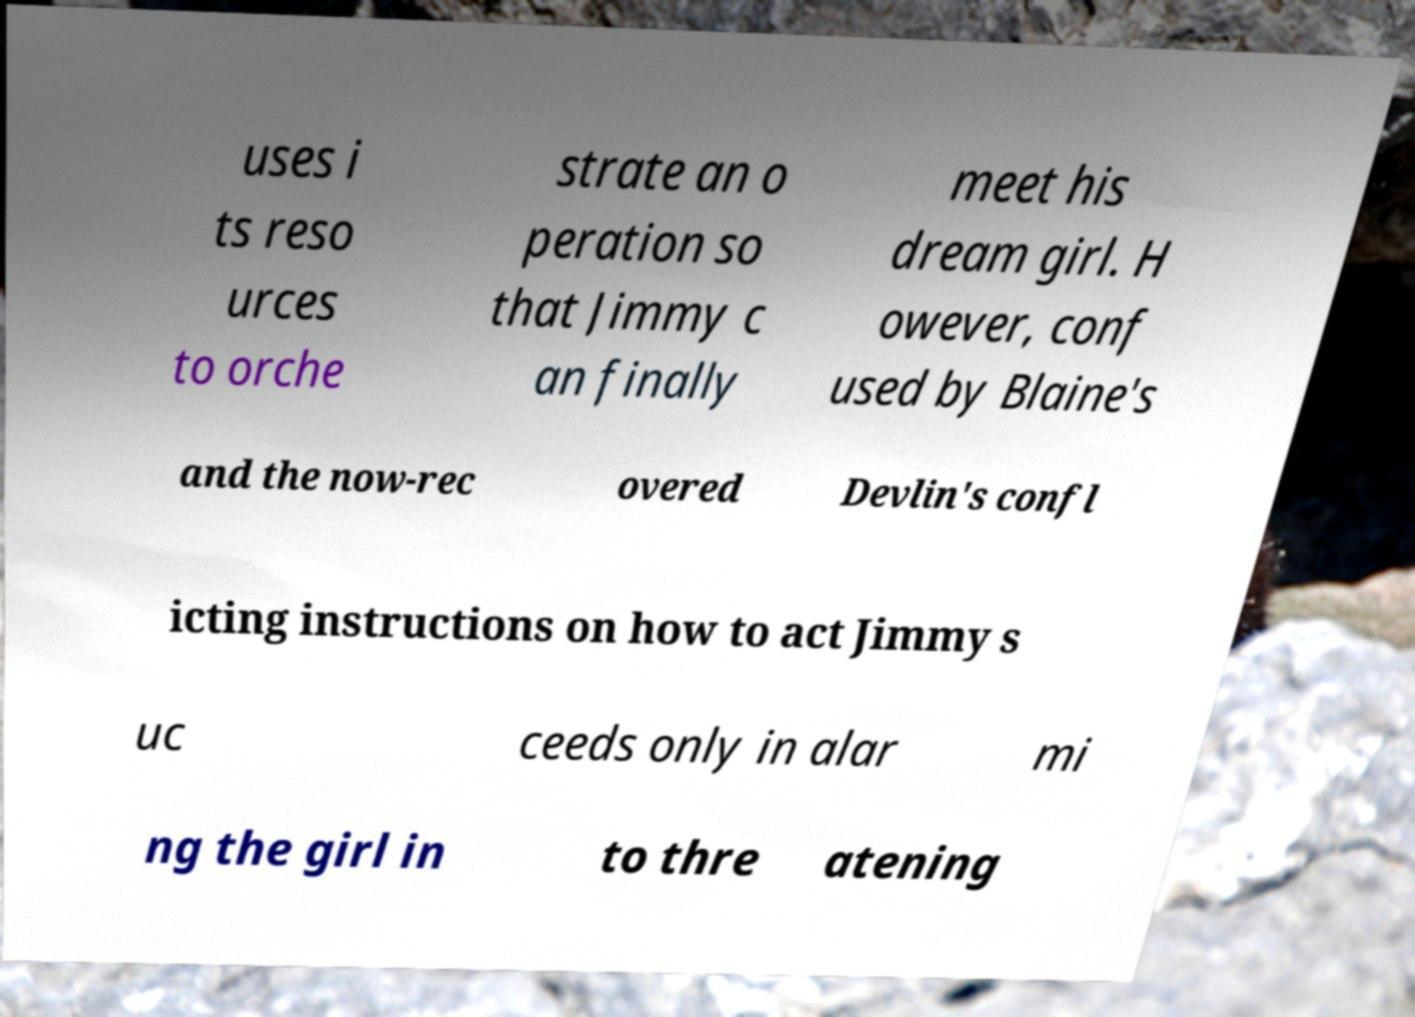Could you extract and type out the text from this image? uses i ts reso urces to orche strate an o peration so that Jimmy c an finally meet his dream girl. H owever, conf used by Blaine's and the now-rec overed Devlin's confl icting instructions on how to act Jimmy s uc ceeds only in alar mi ng the girl in to thre atening 